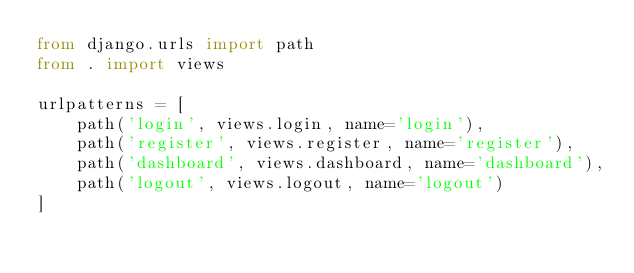Convert code to text. <code><loc_0><loc_0><loc_500><loc_500><_Python_>from django.urls import path
from . import views

urlpatterns = [
    path('login', views.login, name='login'),
    path('register', views.register, name='register'),
    path('dashboard', views.dashboard, name='dashboard'),
    path('logout', views.logout, name='logout')
]</code> 